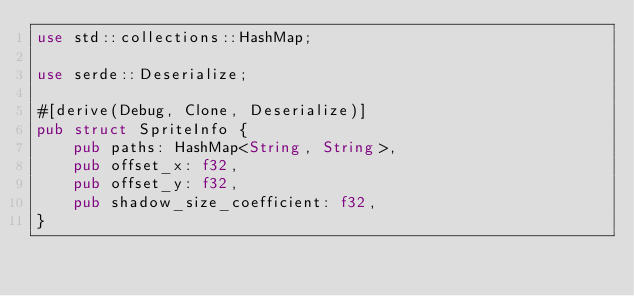<code> <loc_0><loc_0><loc_500><loc_500><_Rust_>use std::collections::HashMap;

use serde::Deserialize;

#[derive(Debug, Clone, Deserialize)]
pub struct SpriteInfo {
    pub paths: HashMap<String, String>,
    pub offset_x: f32,
    pub offset_y: f32,
    pub shadow_size_coefficient: f32,
}
</code> 